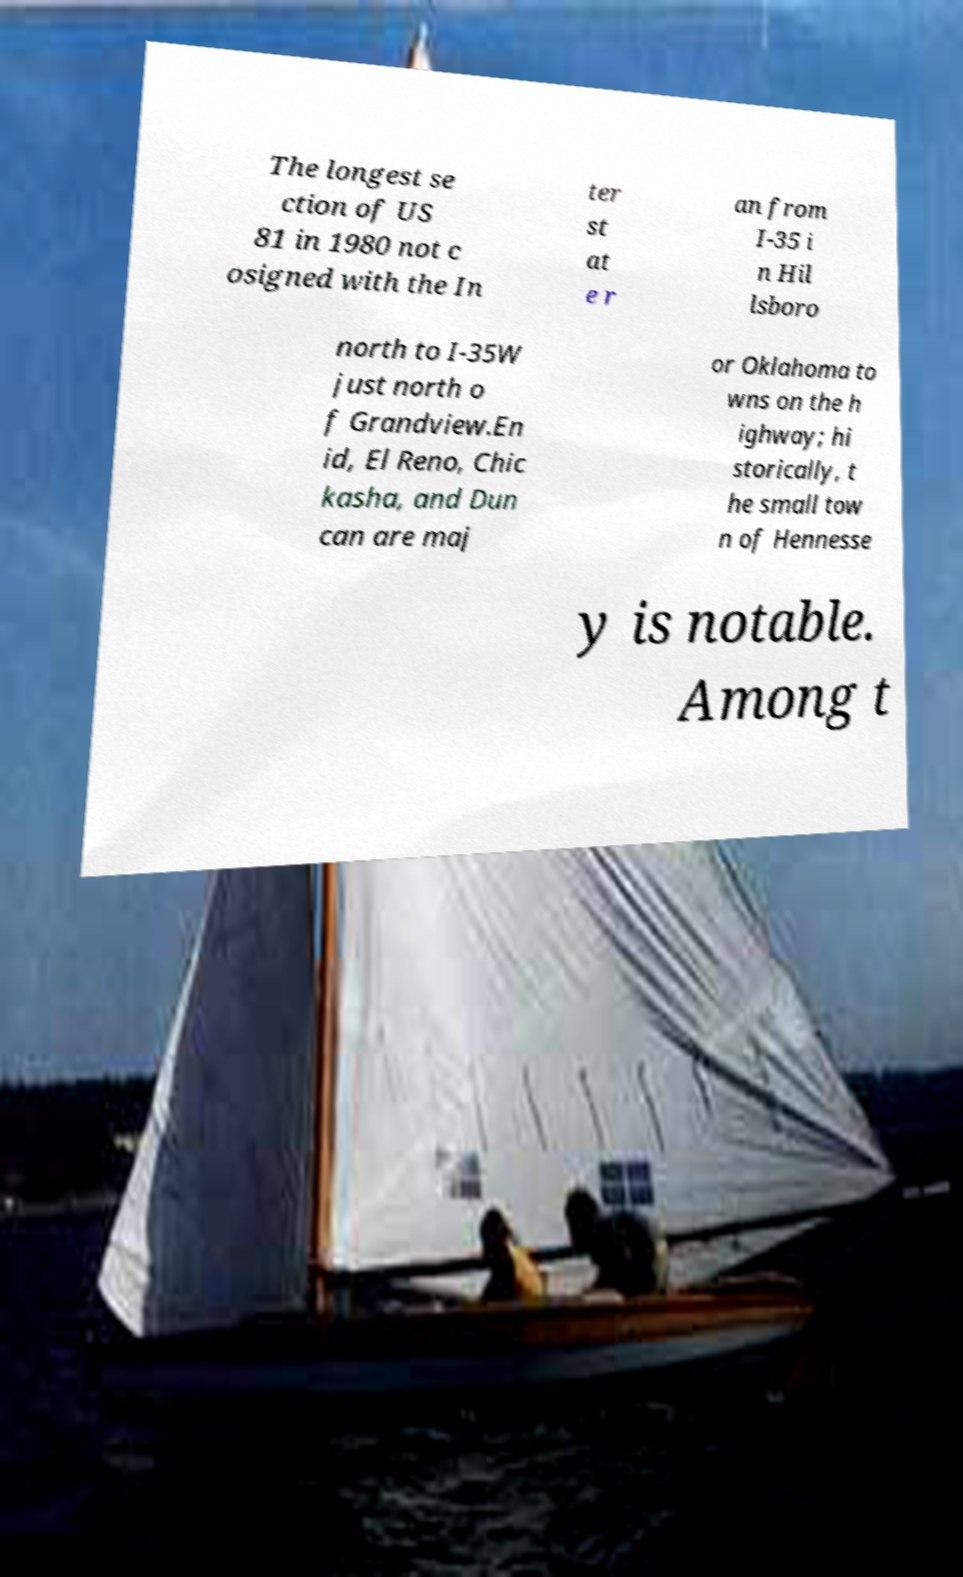I need the written content from this picture converted into text. Can you do that? The longest se ction of US 81 in 1980 not c osigned with the In ter st at e r an from I-35 i n Hil lsboro north to I-35W just north o f Grandview.En id, El Reno, Chic kasha, and Dun can are maj or Oklahoma to wns on the h ighway; hi storically, t he small tow n of Hennesse y is notable. Among t 